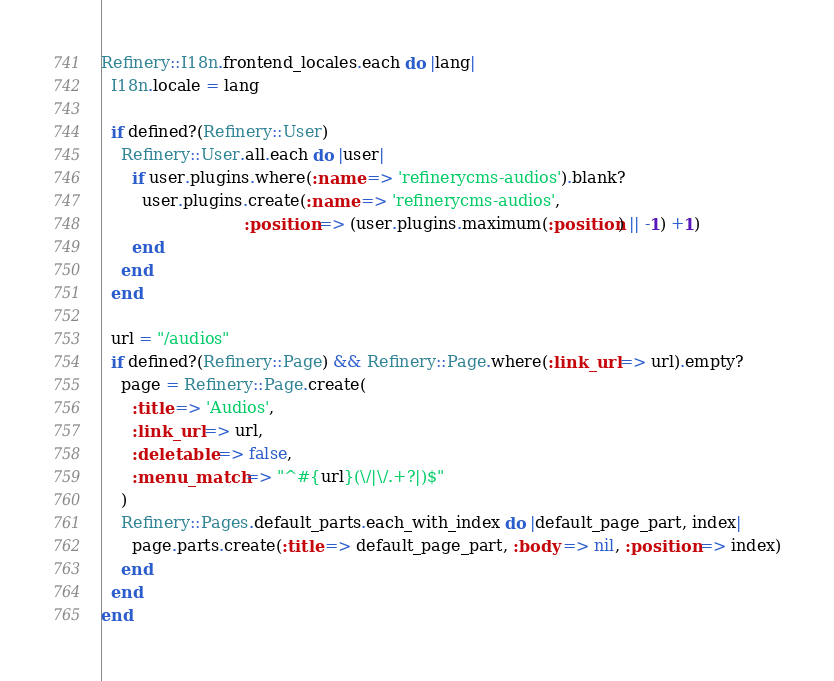<code> <loc_0><loc_0><loc_500><loc_500><_Ruby_>Refinery::I18n.frontend_locales.each do |lang|
  I18n.locale = lang

  if defined?(Refinery::User)
    Refinery::User.all.each do |user|
      if user.plugins.where(:name => 'refinerycms-audios').blank?
        user.plugins.create(:name => 'refinerycms-audios',
                            :position => (user.plugins.maximum(:position) || -1) +1)
      end
    end
  end

  url = "/audios"
  if defined?(Refinery::Page) && Refinery::Page.where(:link_url => url).empty?
    page = Refinery::Page.create(
      :title => 'Audios',
      :link_url => url,
      :deletable => false,
      :menu_match => "^#{url}(\/|\/.+?|)$"
    )
    Refinery::Pages.default_parts.each_with_index do |default_page_part, index|
      page.parts.create(:title => default_page_part, :body => nil, :position => index)
    end
  end
end
</code> 